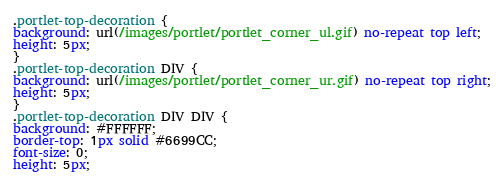<code> <loc_0><loc_0><loc_500><loc_500><_CSS_>.portlet-top-decoration {
background: url(/images/portlet/portlet_corner_ul.gif) no-repeat top left;
height: 5px;
}
.portlet-top-decoration DIV {
background: url(/images/portlet/portlet_corner_ur.gif) no-repeat top right;
height: 5px;
}
.portlet-top-decoration DIV DIV {
background: #FFFFFF;
border-top: 1px solid #6699CC;
font-size: 0;
height: 5px;</code> 